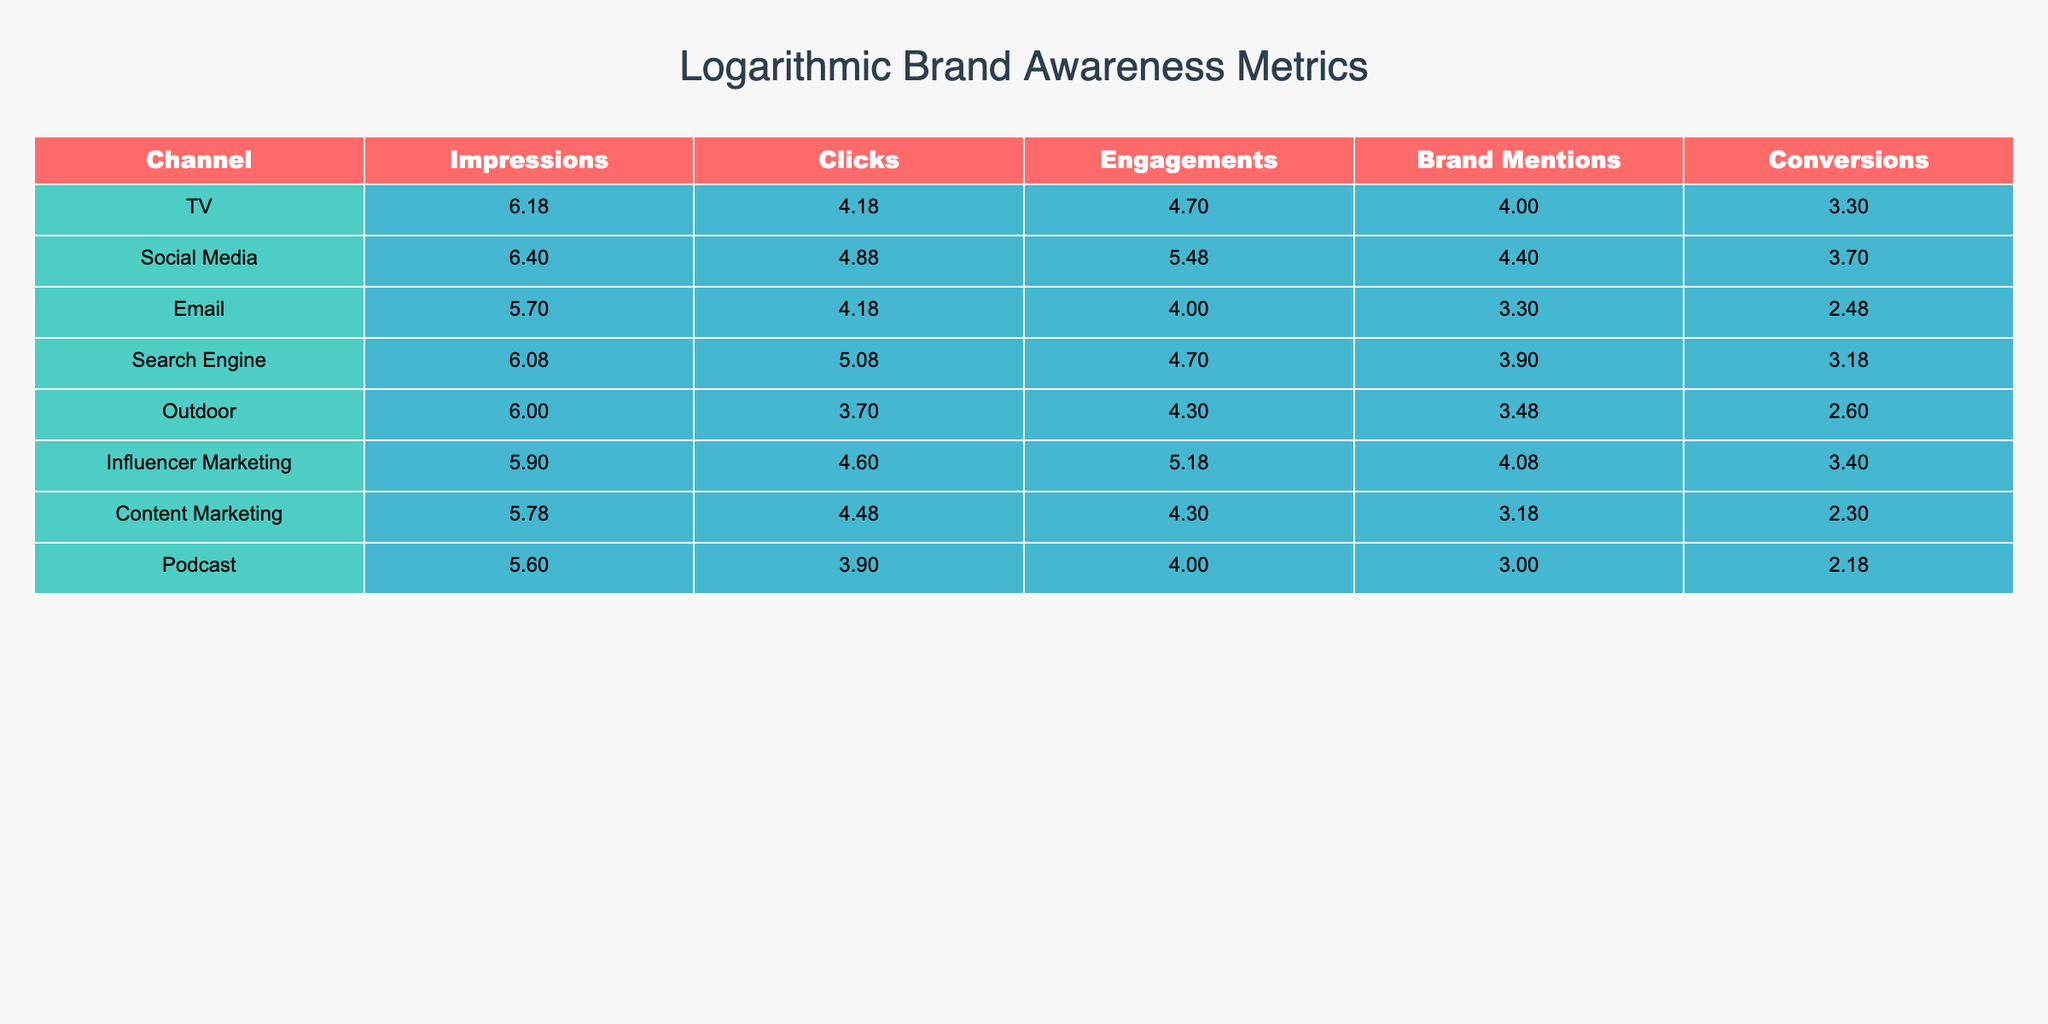What are the impressions for the Email channel? The table shows the column for impressions, where the value corresponding to the Email channel is provided directly. Looking at the 'Impressions' row for Email, the value is 500000.
Answer: 500000 Which advertising channel has the highest conversions? By looking at the 'Conversions' column, we can compare the values for each channel. The highest value is for the Social Media channel, which has 5000 conversions.
Answer: Social Media What is the total number of engagements across all channels? To find the total engagements, we add up the engagements for each channel: 50000 (TV) + 300000 (Social Media) + 10000 (Email) + 50000 (Search Engine) + 20000 (Outdoor) + 150000 (Influencer Marketing) + 20000 (Content Marketing) + 10000 (Podcast) = 500000.
Answer: 500000 Is it true that the Outdoor channel had more conversions than the Podcast channel? By checking the 'Conversions' for both channels, we see 400 for Outdoor and 150 for Podcast. Thus, Outdoor had more conversions, making the statement true.
Answer: Yes What is the average number of brand mentions across all channels? First, we find the total brand mentions: 10000 (TV) + 25000 (Social Media) + 2000 (Email) + 8000 (Search Engine) + 3000 (Outdoor) + 12000 (Influencer Marketing) + 1500 (Content Marketing) + 1000 (Podcast) = 65000. There are 8 channels, so we divide 65000 by 8 to get the average, which is 8125.
Answer: 8125 Which channel has the second highest number of impressions? The values in the 'Impressions' column are arranged as follows: Social Media (2500000), TV (1500000), Search Engine (1200000), Outdoor (1000000), Influencer Marketing (800000), Content Marketing (600000), Email (500000), and Podcast (400000). The second largest value is 1500000, corresponding to the TV channel.
Answer: TV How many clicks does the Influencer Marketing channel generate compared to the Email channel? The table shows 40000 clicks for Influencer Marketing and 15000 for Email. The difference is found by subtracting Email's clicks from Influencer Marketing's clicks: 40000 - 15000 = 25000.
Answer: 25000 What is the ratio of conversions to impressions for the Search Engine channel? For the Search Engine channel, the conversions are 1500 and the impressions are 1200000. The ratio is calculated as 1500/1200000, which simplifies to 0.00125. Therefore, the ratio of conversions to impressions is 0.00125.
Answer: 0.00125 